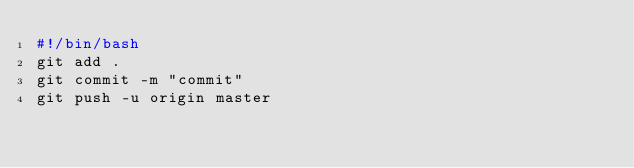<code> <loc_0><loc_0><loc_500><loc_500><_Bash_>#!/bin/bash
git add .
git commit -m "commit"
git push -u origin master</code> 